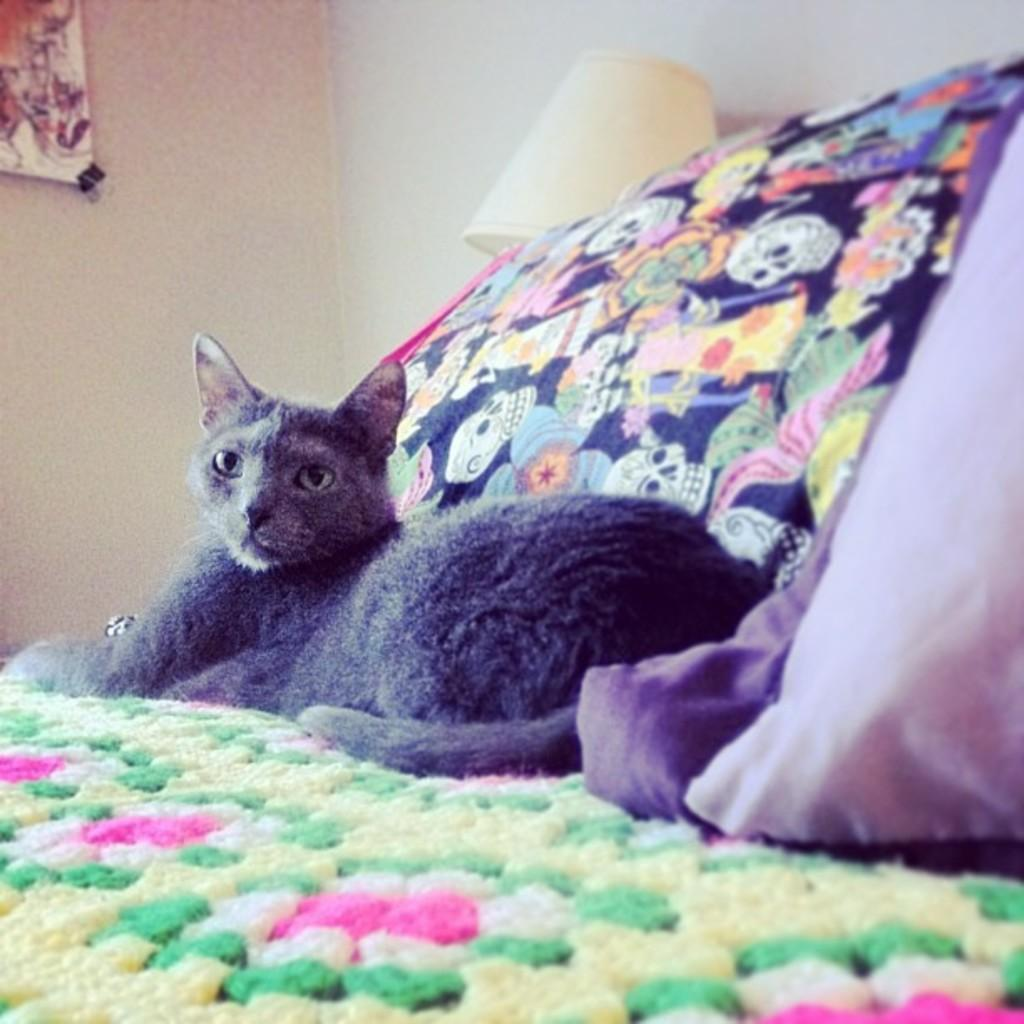What animal can be seen on the bed in the image? There is a cat lying on the bed in the image. What type of light is visible in the image? There is a light in the image. What type of decoration is present on the wall in the image? There is a wall painting in the image. What type of soap is being used to clean the cat in the image? There is no soap or cleaning activity involving the cat in the image. 